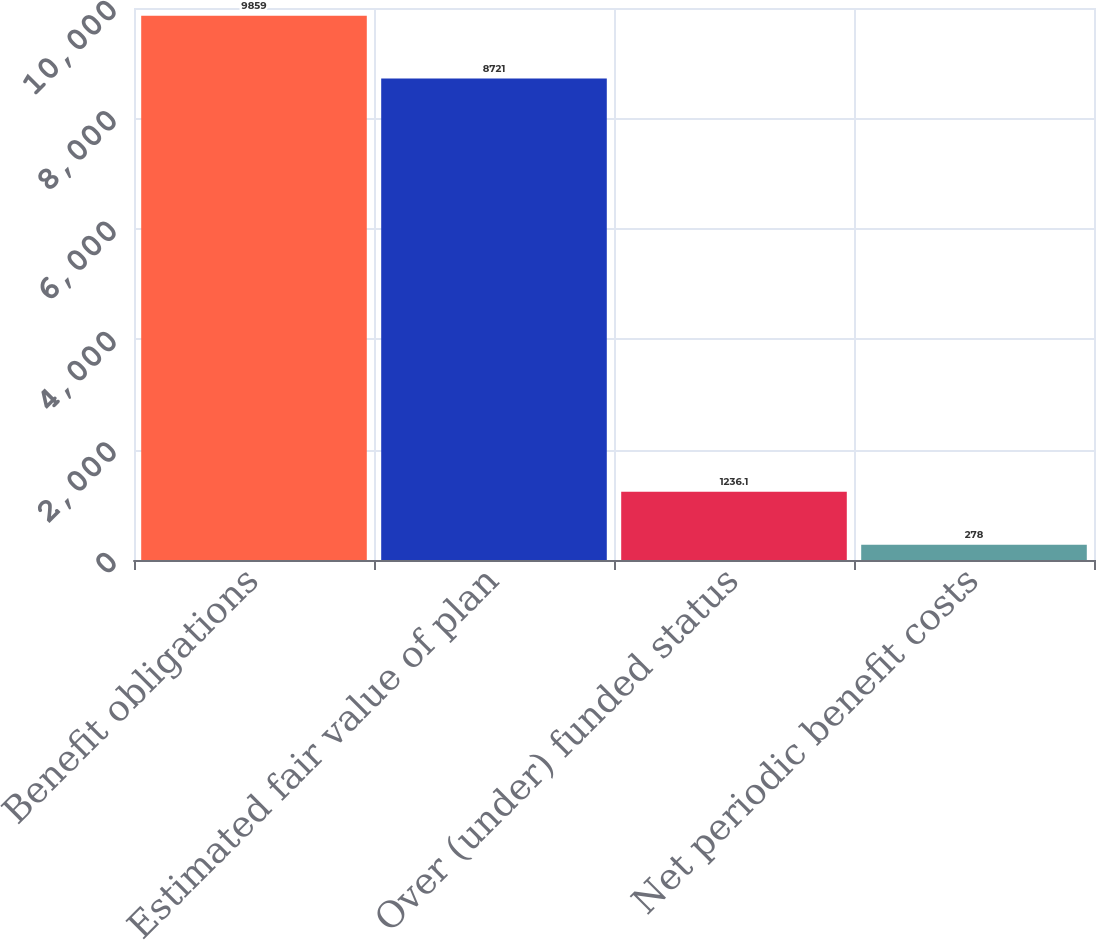Convert chart. <chart><loc_0><loc_0><loc_500><loc_500><bar_chart><fcel>Benefit obligations<fcel>Estimated fair value of plan<fcel>Over (under) funded status<fcel>Net periodic benefit costs<nl><fcel>9859<fcel>8721<fcel>1236.1<fcel>278<nl></chart> 